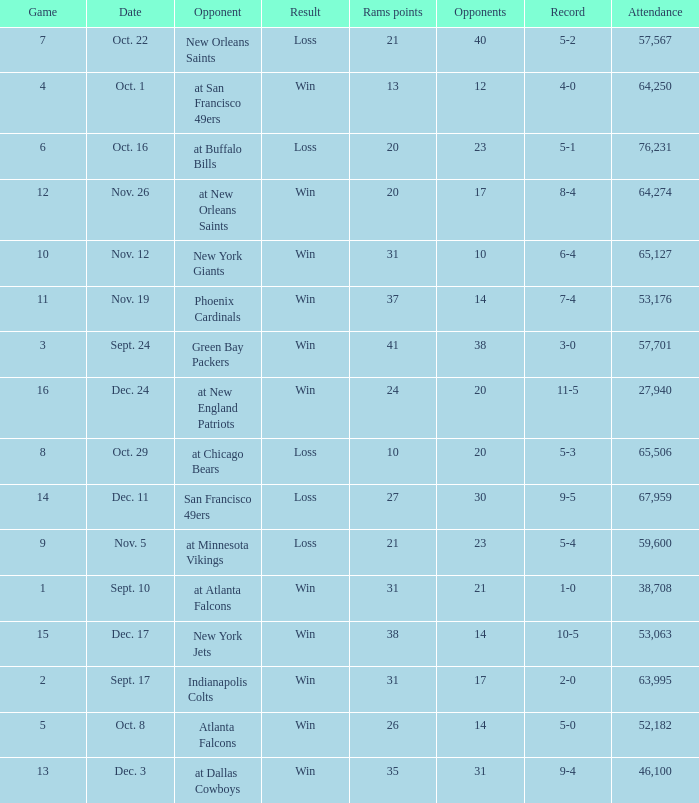What was the attendance where the record was 8-4? 64274.0. 